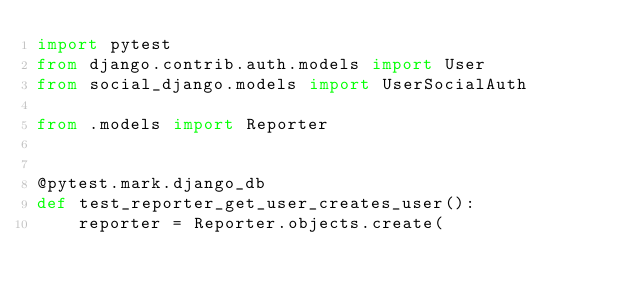Convert code to text. <code><loc_0><loc_0><loc_500><loc_500><_Python_>import pytest
from django.contrib.auth.models import User
from social_django.models import UserSocialAuth

from .models import Reporter


@pytest.mark.django_db
def test_reporter_get_user_creates_user():
    reporter = Reporter.objects.create(</code> 